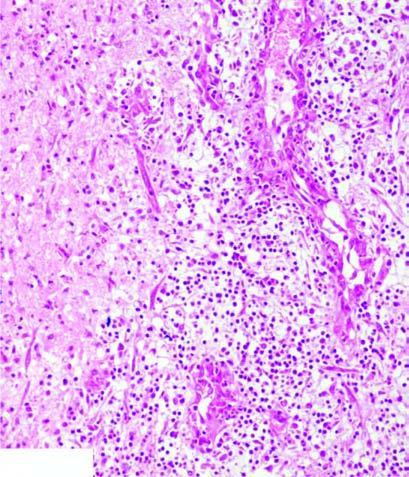where is the necrosed area?
Answer the question using a single word or phrase. On right side of the field 